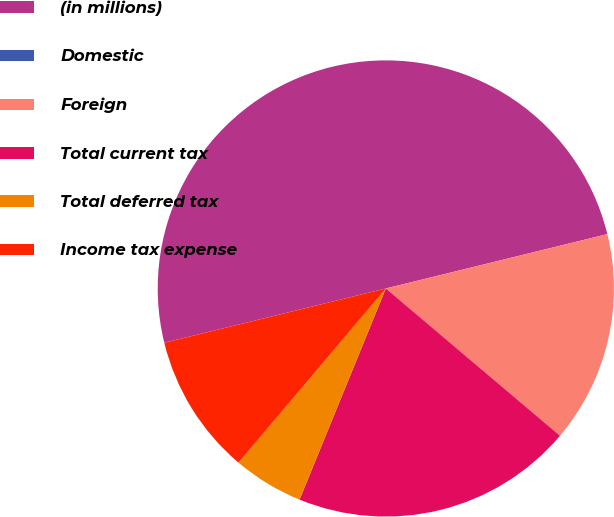Convert chart. <chart><loc_0><loc_0><loc_500><loc_500><pie_chart><fcel>(in millions)<fcel>Domestic<fcel>Foreign<fcel>Total current tax<fcel>Total deferred tax<fcel>Income tax expense<nl><fcel>49.99%<fcel>0.0%<fcel>15.0%<fcel>20.0%<fcel>5.0%<fcel>10.0%<nl></chart> 